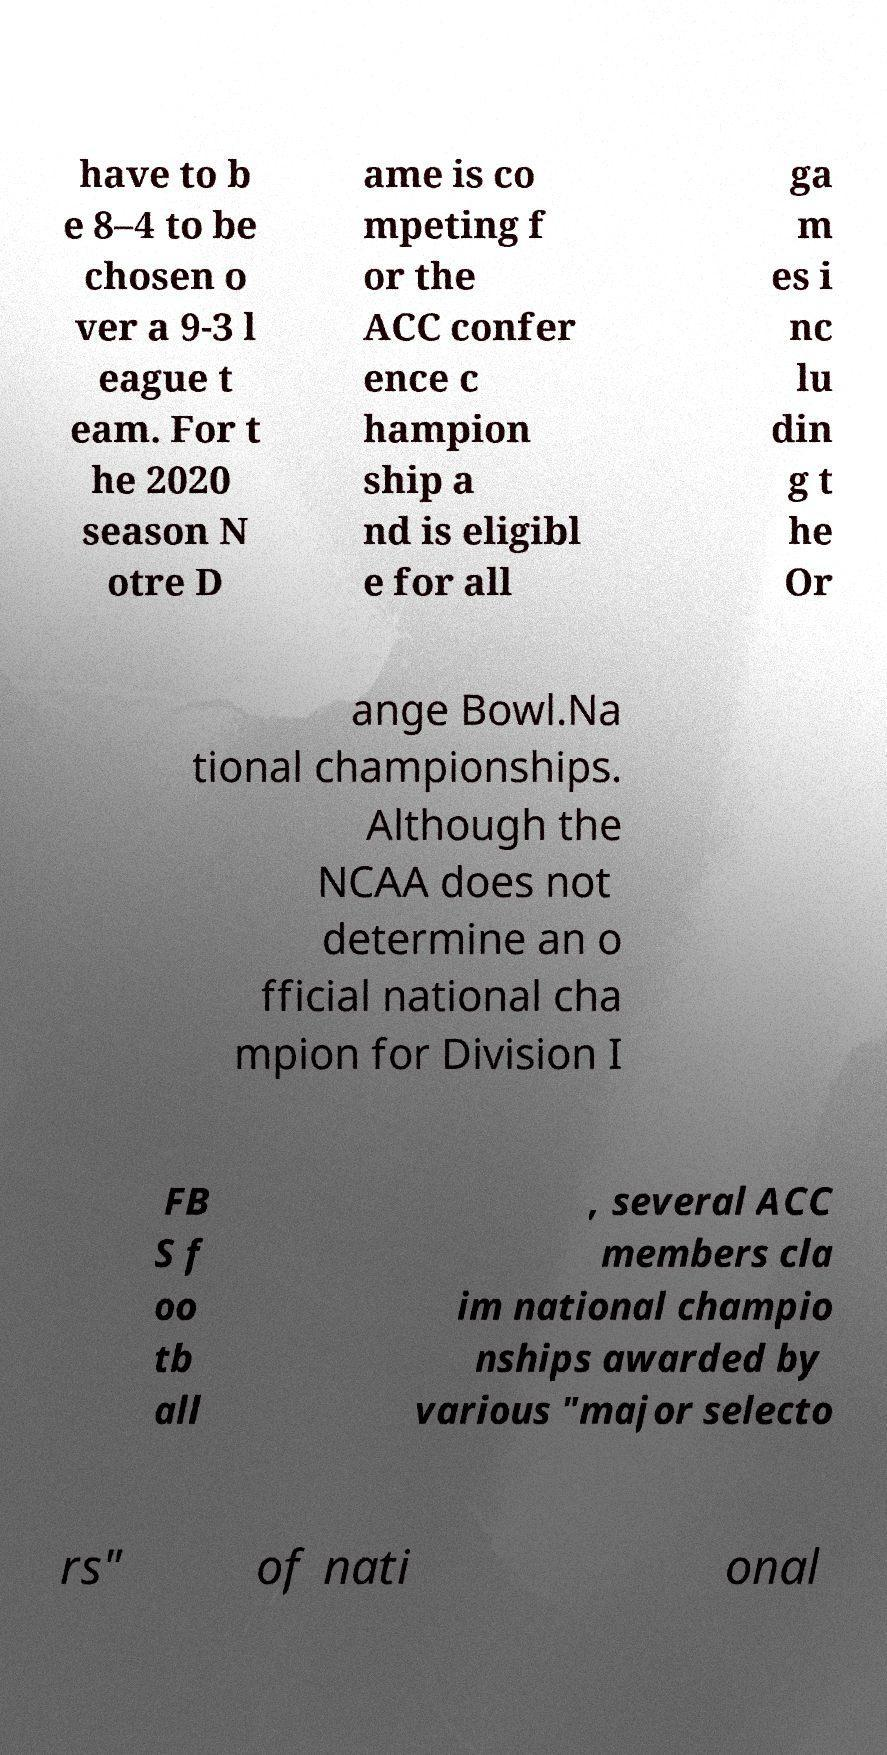Can you read and provide the text displayed in the image?This photo seems to have some interesting text. Can you extract and type it out for me? have to b e 8–4 to be chosen o ver a 9-3 l eague t eam. For t he 2020 season N otre D ame is co mpeting f or the ACC confer ence c hampion ship a nd is eligibl e for all ga m es i nc lu din g t he Or ange Bowl.Na tional championships. Although the NCAA does not determine an o fficial national cha mpion for Division I FB S f oo tb all , several ACC members cla im national champio nships awarded by various "major selecto rs" of nati onal 